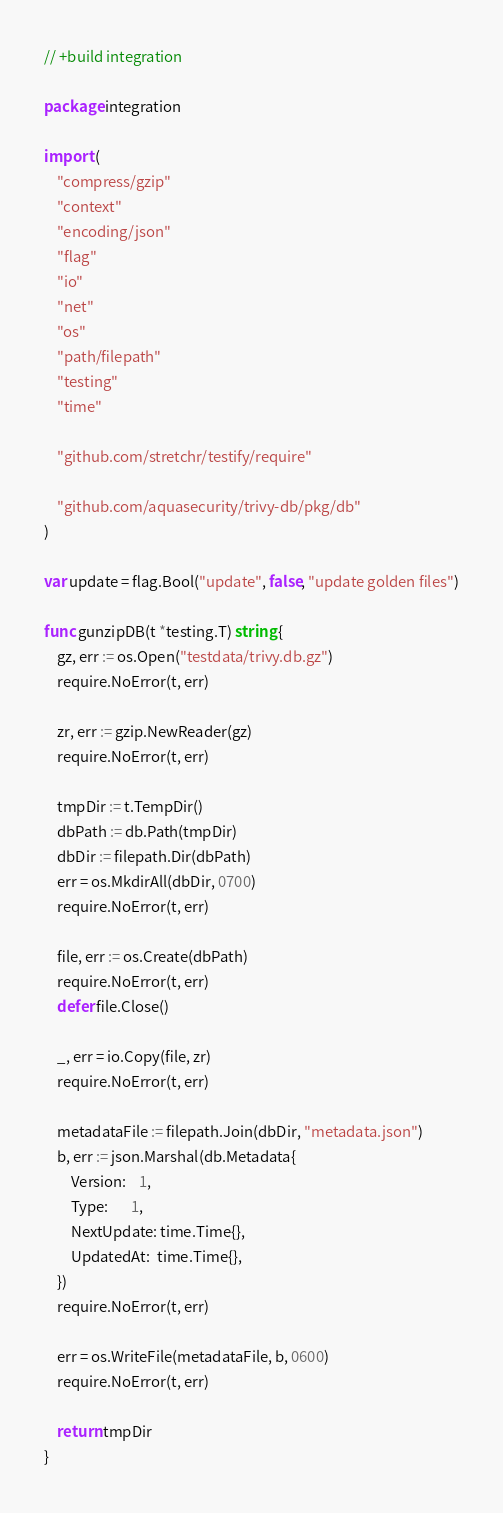<code> <loc_0><loc_0><loc_500><loc_500><_Go_>// +build integration

package integration

import (
	"compress/gzip"
	"context"
	"encoding/json"
	"flag"
	"io"
	"net"
	"os"
	"path/filepath"
	"testing"
	"time"

	"github.com/stretchr/testify/require"

	"github.com/aquasecurity/trivy-db/pkg/db"
)

var update = flag.Bool("update", false, "update golden files")

func gunzipDB(t *testing.T) string {
	gz, err := os.Open("testdata/trivy.db.gz")
	require.NoError(t, err)

	zr, err := gzip.NewReader(gz)
	require.NoError(t, err)

	tmpDir := t.TempDir()
	dbPath := db.Path(tmpDir)
	dbDir := filepath.Dir(dbPath)
	err = os.MkdirAll(dbDir, 0700)
	require.NoError(t, err)

	file, err := os.Create(dbPath)
	require.NoError(t, err)
	defer file.Close()

	_, err = io.Copy(file, zr)
	require.NoError(t, err)

	metadataFile := filepath.Join(dbDir, "metadata.json")
	b, err := json.Marshal(db.Metadata{
		Version:    1,
		Type:       1,
		NextUpdate: time.Time{},
		UpdatedAt:  time.Time{},
	})
	require.NoError(t, err)

	err = os.WriteFile(metadataFile, b, 0600)
	require.NoError(t, err)

	return tmpDir
}
</code> 